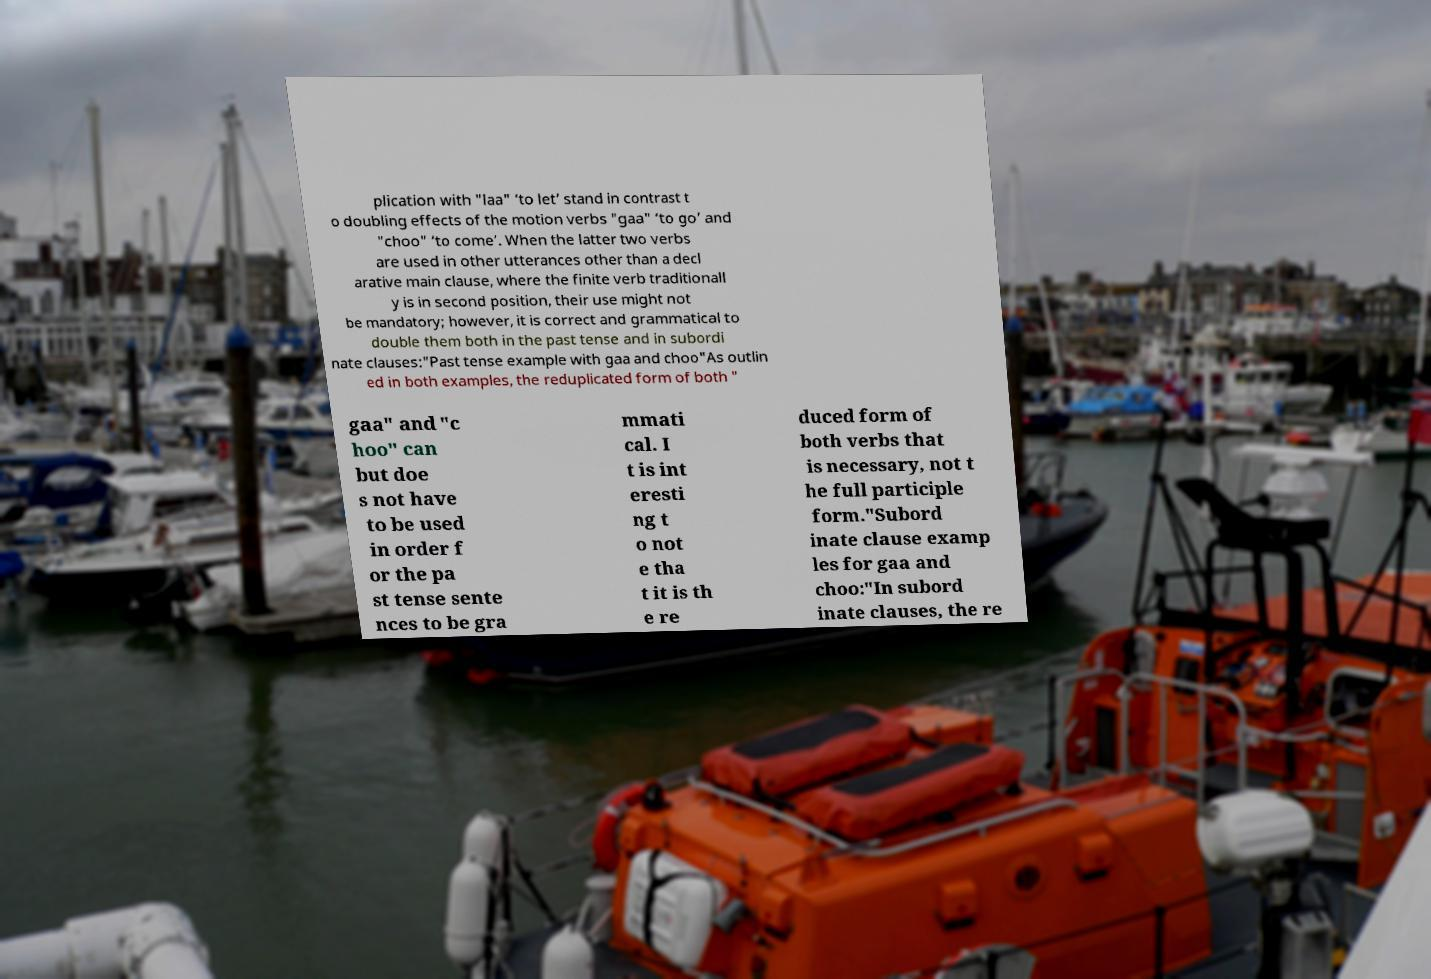Could you assist in decoding the text presented in this image and type it out clearly? plication with "laa" ‘to let’ stand in contrast t o doubling effects of the motion verbs "gaa" ‘to go’ and "choo" ‘to come’. When the latter two verbs are used in other utterances other than a decl arative main clause, where the finite verb traditionall y is in second position, their use might not be mandatory; however, it is correct and grammatical to double them both in the past tense and in subordi nate clauses:"Past tense example with gaa and choo"As outlin ed in both examples, the reduplicated form of both " gaa" and "c hoo" can but doe s not have to be used in order f or the pa st tense sente nces to be gra mmati cal. I t is int eresti ng t o not e tha t it is th e re duced form of both verbs that is necessary, not t he full participle form."Subord inate clause examp les for gaa and choo:"In subord inate clauses, the re 